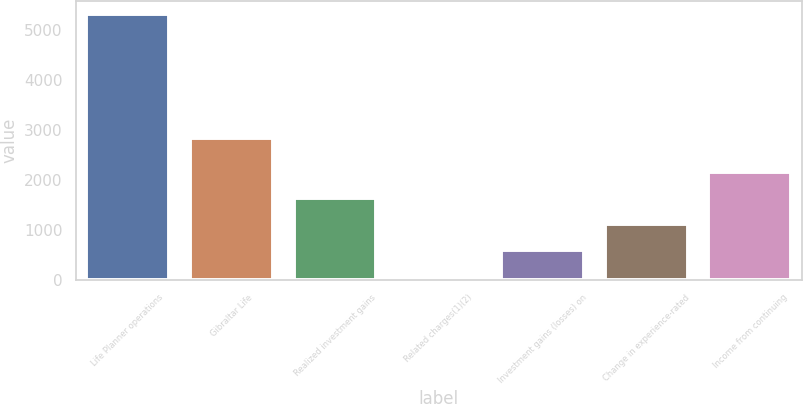Convert chart. <chart><loc_0><loc_0><loc_500><loc_500><bar_chart><fcel>Life Planner operations<fcel>Gibraltar Life<fcel>Realized investment gains<fcel>Related charges(1)(2)<fcel>Investment gains (losses) on<fcel>Change in experience-rated<fcel>Income from continuing<nl><fcel>5313<fcel>2835<fcel>1636.6<fcel>61<fcel>586.2<fcel>1111.4<fcel>2161.8<nl></chart> 